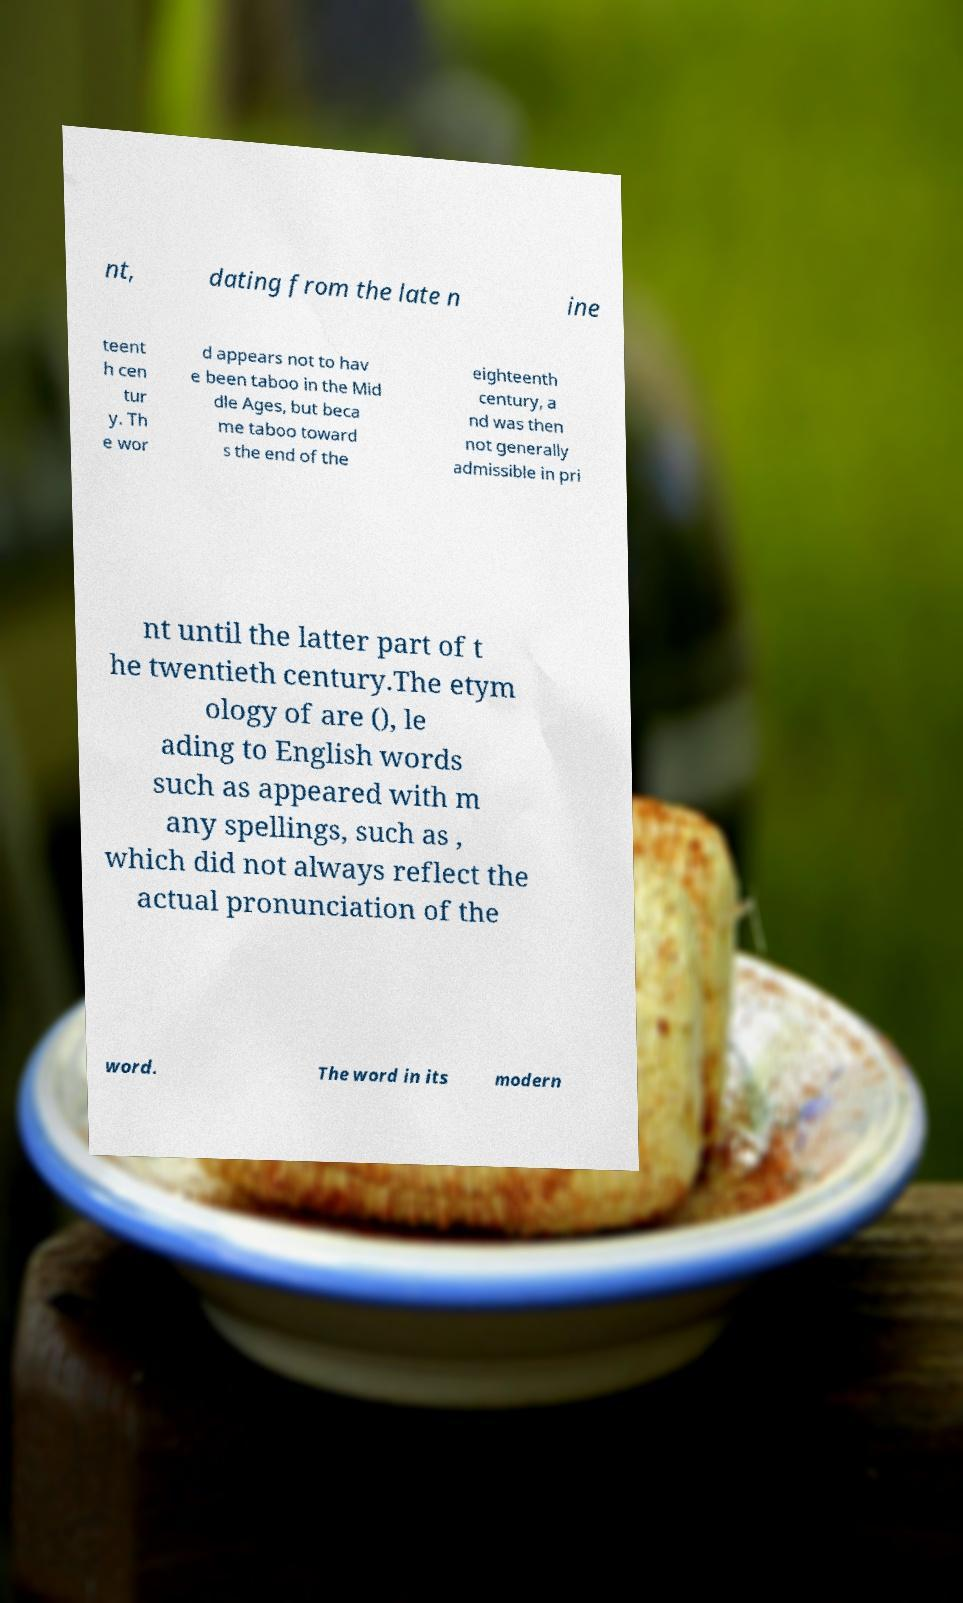What messages or text are displayed in this image? I need them in a readable, typed format. nt, dating from the late n ine teent h cen tur y. Th e wor d appears not to hav e been taboo in the Mid dle Ages, but beca me taboo toward s the end of the eighteenth century, a nd was then not generally admissible in pri nt until the latter part of t he twentieth century.The etym ology of are (), le ading to English words such as appeared with m any spellings, such as , which did not always reflect the actual pronunciation of the word. The word in its modern 